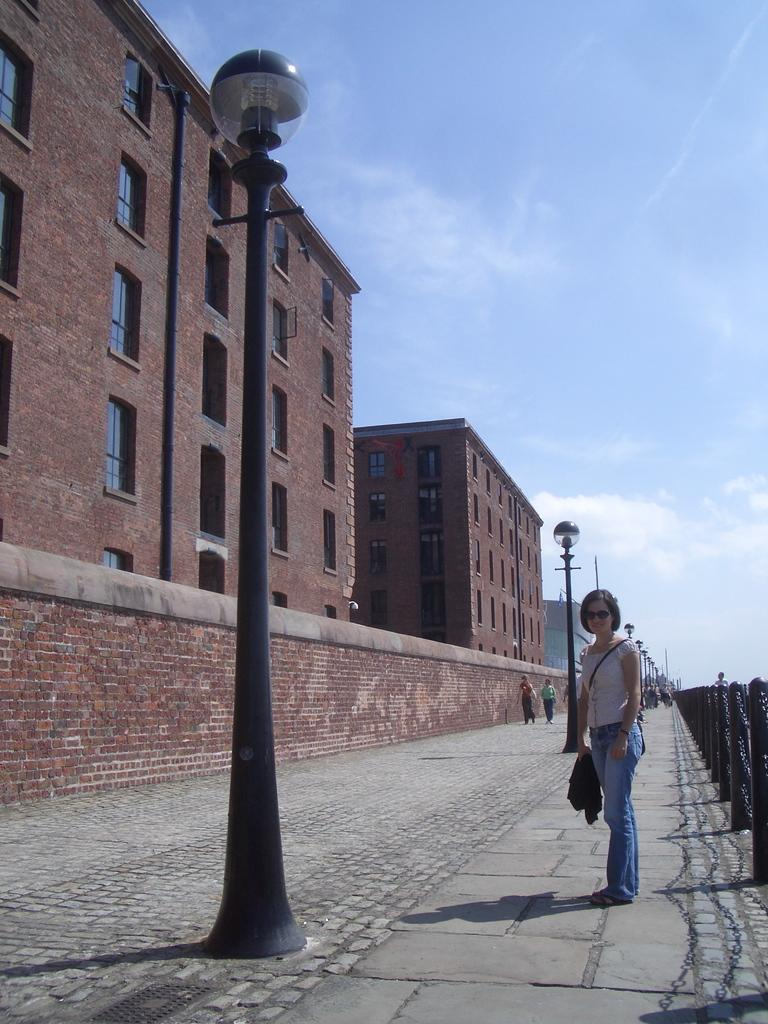What type of structures can be seen in the image? There are buildings in the image. What type of lighting is present in the image? There are pole lights in the image. Who is present in the image? A woman is standing in the image, and there are people walking on the sidewalk. What type of barrier is visible in the image? There is a metal fence in the image. How would you describe the sky in the image? The sky is blue and cloudy in the image. What type of seed is being planted by the woman in the image? There is no seed or planting activity depicted in the image. What type of banana is being eaten by the people walking on the sidewalk? There is no banana or eating activity depicted in the image. 